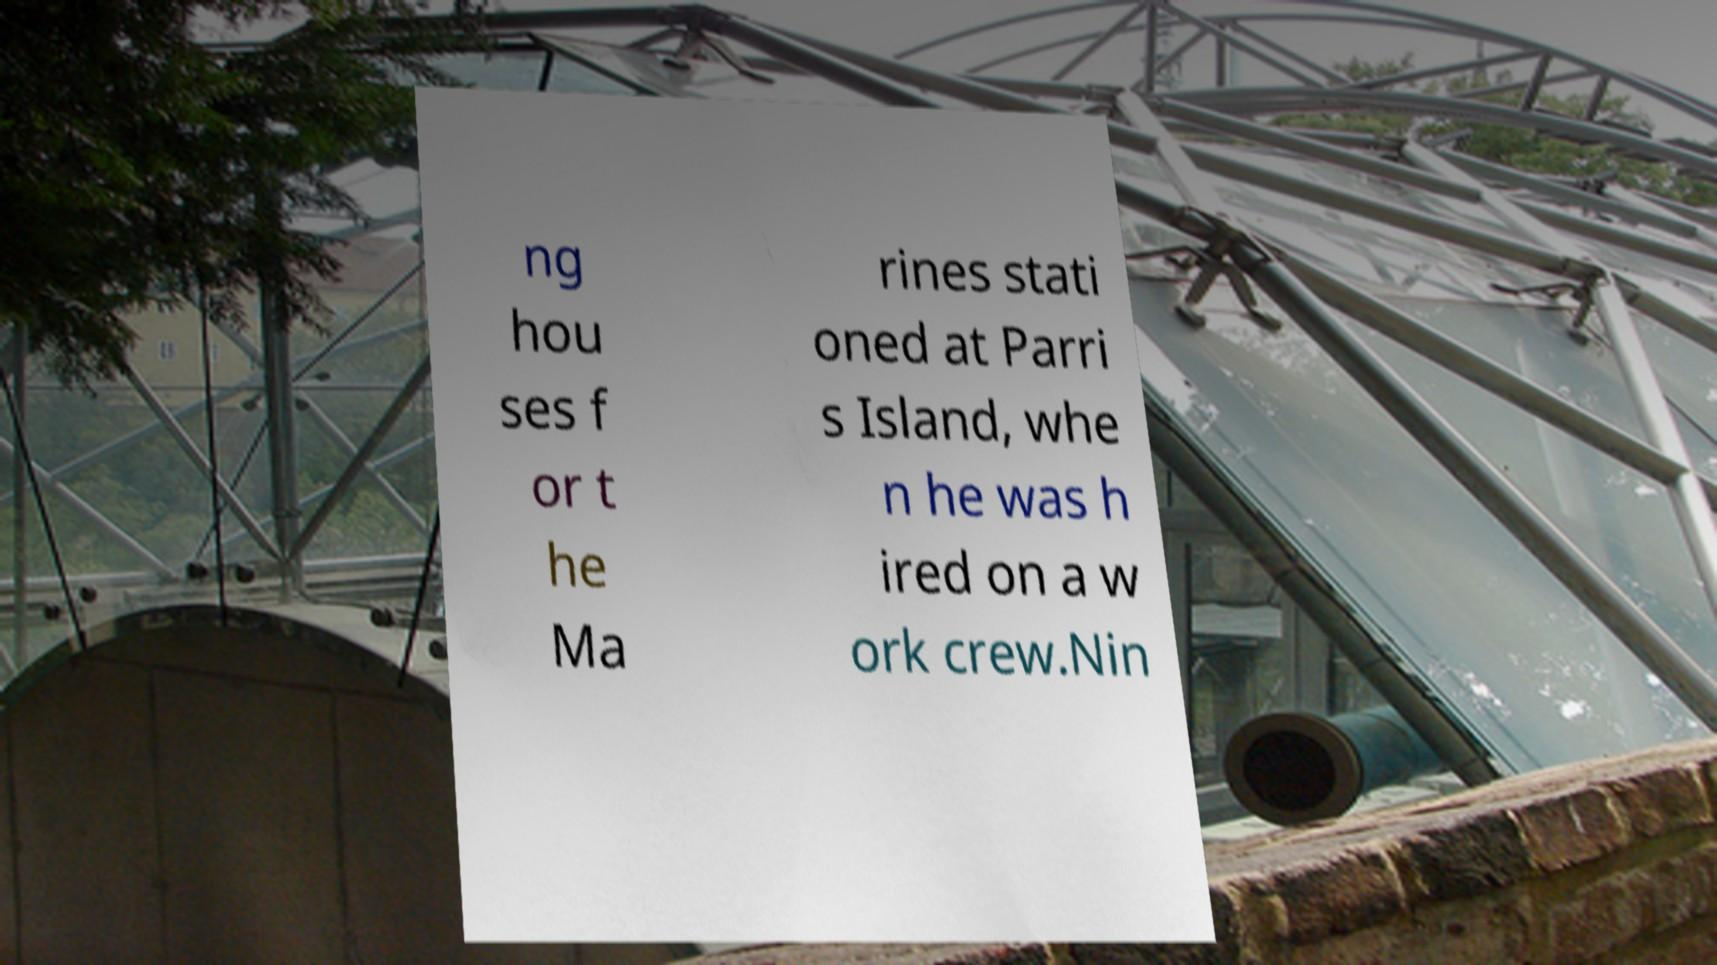Please read and relay the text visible in this image. What does it say? ng hou ses f or t he Ma rines stati oned at Parri s Island, whe n he was h ired on a w ork crew.Nin 